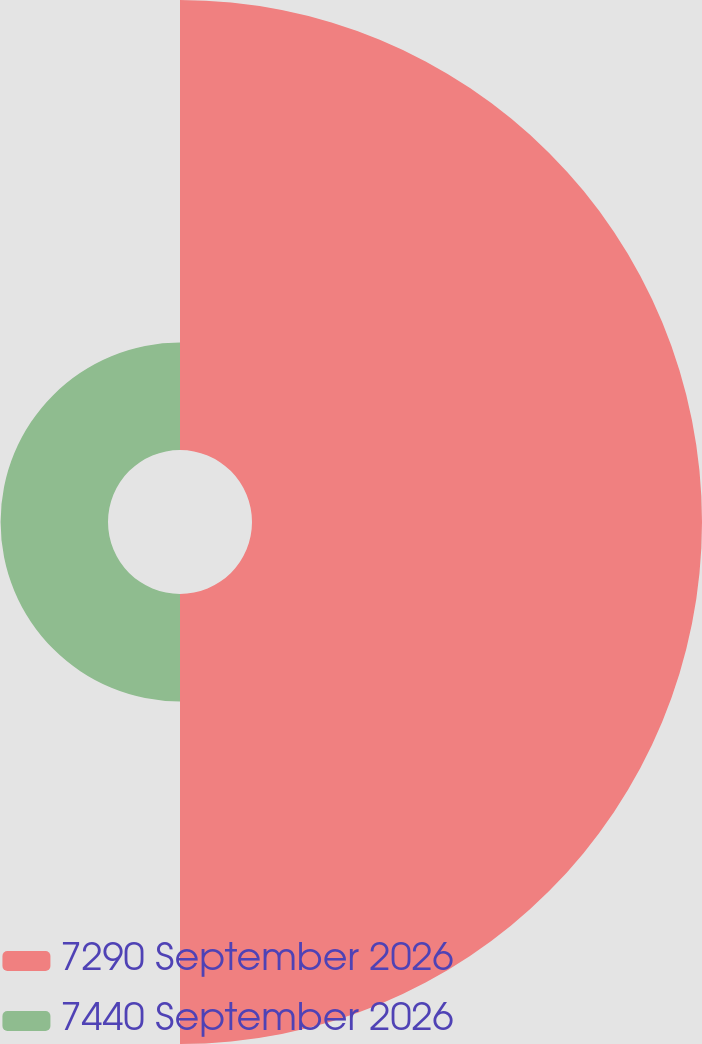Convert chart. <chart><loc_0><loc_0><loc_500><loc_500><pie_chart><fcel>7290 September 2026<fcel>7440 September 2026<nl><fcel>80.73%<fcel>19.27%<nl></chart> 